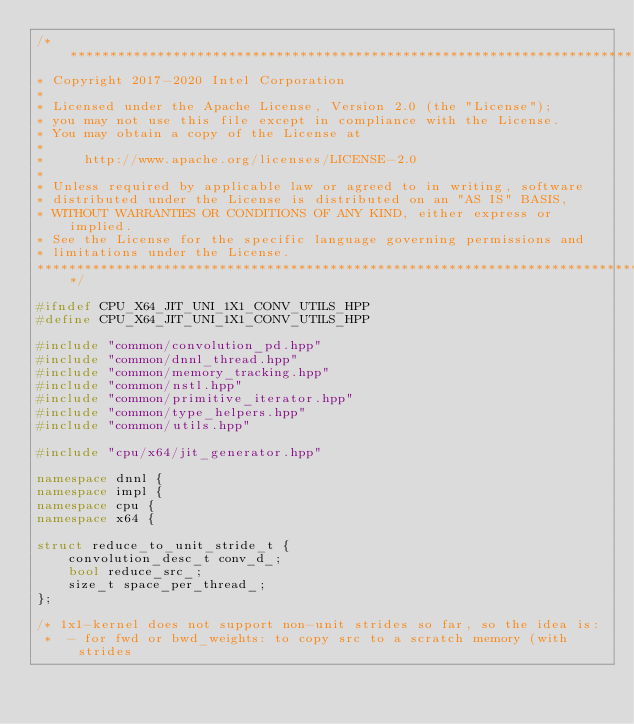<code> <loc_0><loc_0><loc_500><loc_500><_C++_>/*******************************************************************************
* Copyright 2017-2020 Intel Corporation
*
* Licensed under the Apache License, Version 2.0 (the "License");
* you may not use this file except in compliance with the License.
* You may obtain a copy of the License at
*
*     http://www.apache.org/licenses/LICENSE-2.0
*
* Unless required by applicable law or agreed to in writing, software
* distributed under the License is distributed on an "AS IS" BASIS,
* WITHOUT WARRANTIES OR CONDITIONS OF ANY KIND, either express or implied.
* See the License for the specific language governing permissions and
* limitations under the License.
*******************************************************************************/

#ifndef CPU_X64_JIT_UNI_1X1_CONV_UTILS_HPP
#define CPU_X64_JIT_UNI_1X1_CONV_UTILS_HPP

#include "common/convolution_pd.hpp"
#include "common/dnnl_thread.hpp"
#include "common/memory_tracking.hpp"
#include "common/nstl.hpp"
#include "common/primitive_iterator.hpp"
#include "common/type_helpers.hpp"
#include "common/utils.hpp"

#include "cpu/x64/jit_generator.hpp"

namespace dnnl {
namespace impl {
namespace cpu {
namespace x64 {

struct reduce_to_unit_stride_t {
    convolution_desc_t conv_d_;
    bool reduce_src_;
    size_t space_per_thread_;
};

/* 1x1-kernel does not support non-unit strides so far, so the idea is:
 *  - for fwd or bwd_weights: to copy src to a scratch memory (with strides</code> 